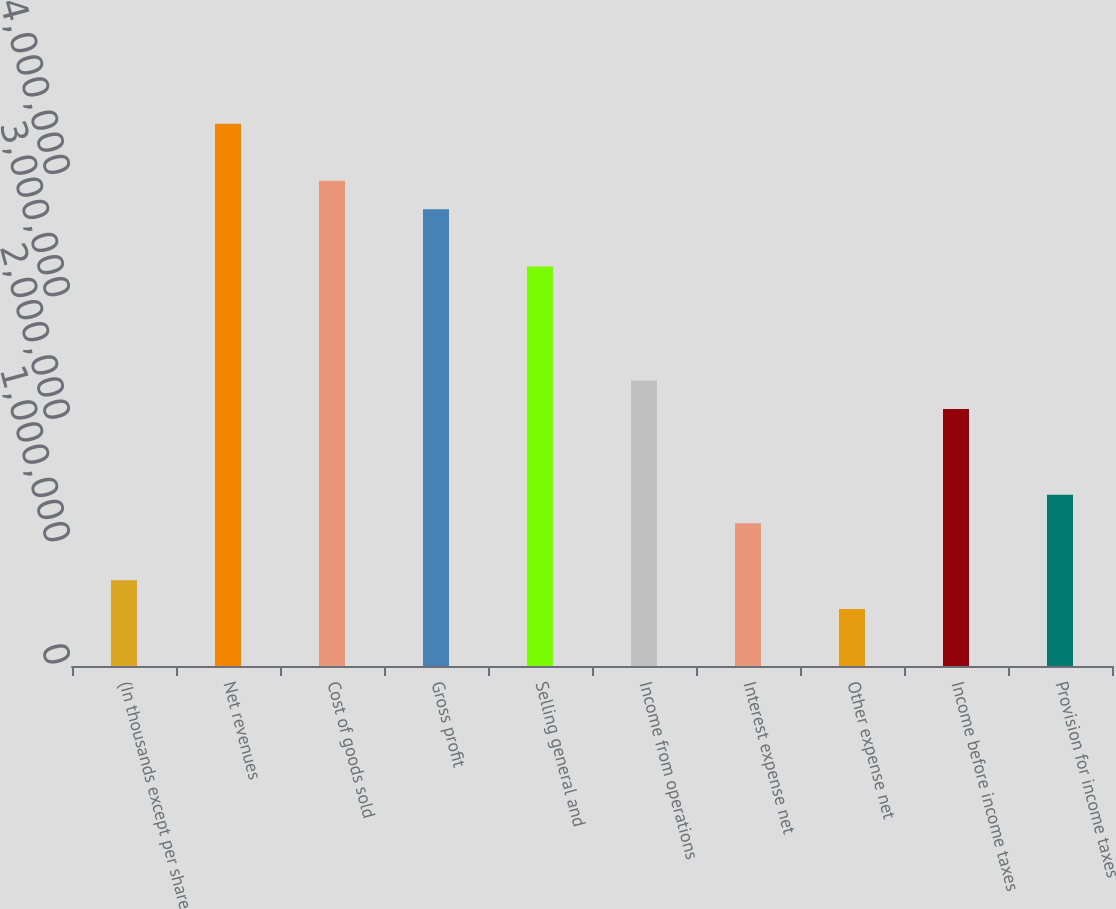<chart> <loc_0><loc_0><loc_500><loc_500><bar_chart><fcel>(In thousands except per share<fcel>Net revenues<fcel>Cost of goods sold<fcel>Gross profit<fcel>Selling general and<fcel>Income from operations<fcel>Interest expense net<fcel>Other expense net<fcel>Income before income taxes<fcel>Provision for income taxes<nl><fcel>699616<fcel>4.4309e+06<fcel>3.96449e+06<fcel>3.73128e+06<fcel>3.26487e+06<fcel>2.33205e+06<fcel>1.16603e+06<fcel>466411<fcel>2.09885e+06<fcel>1.39923e+06<nl></chart> 